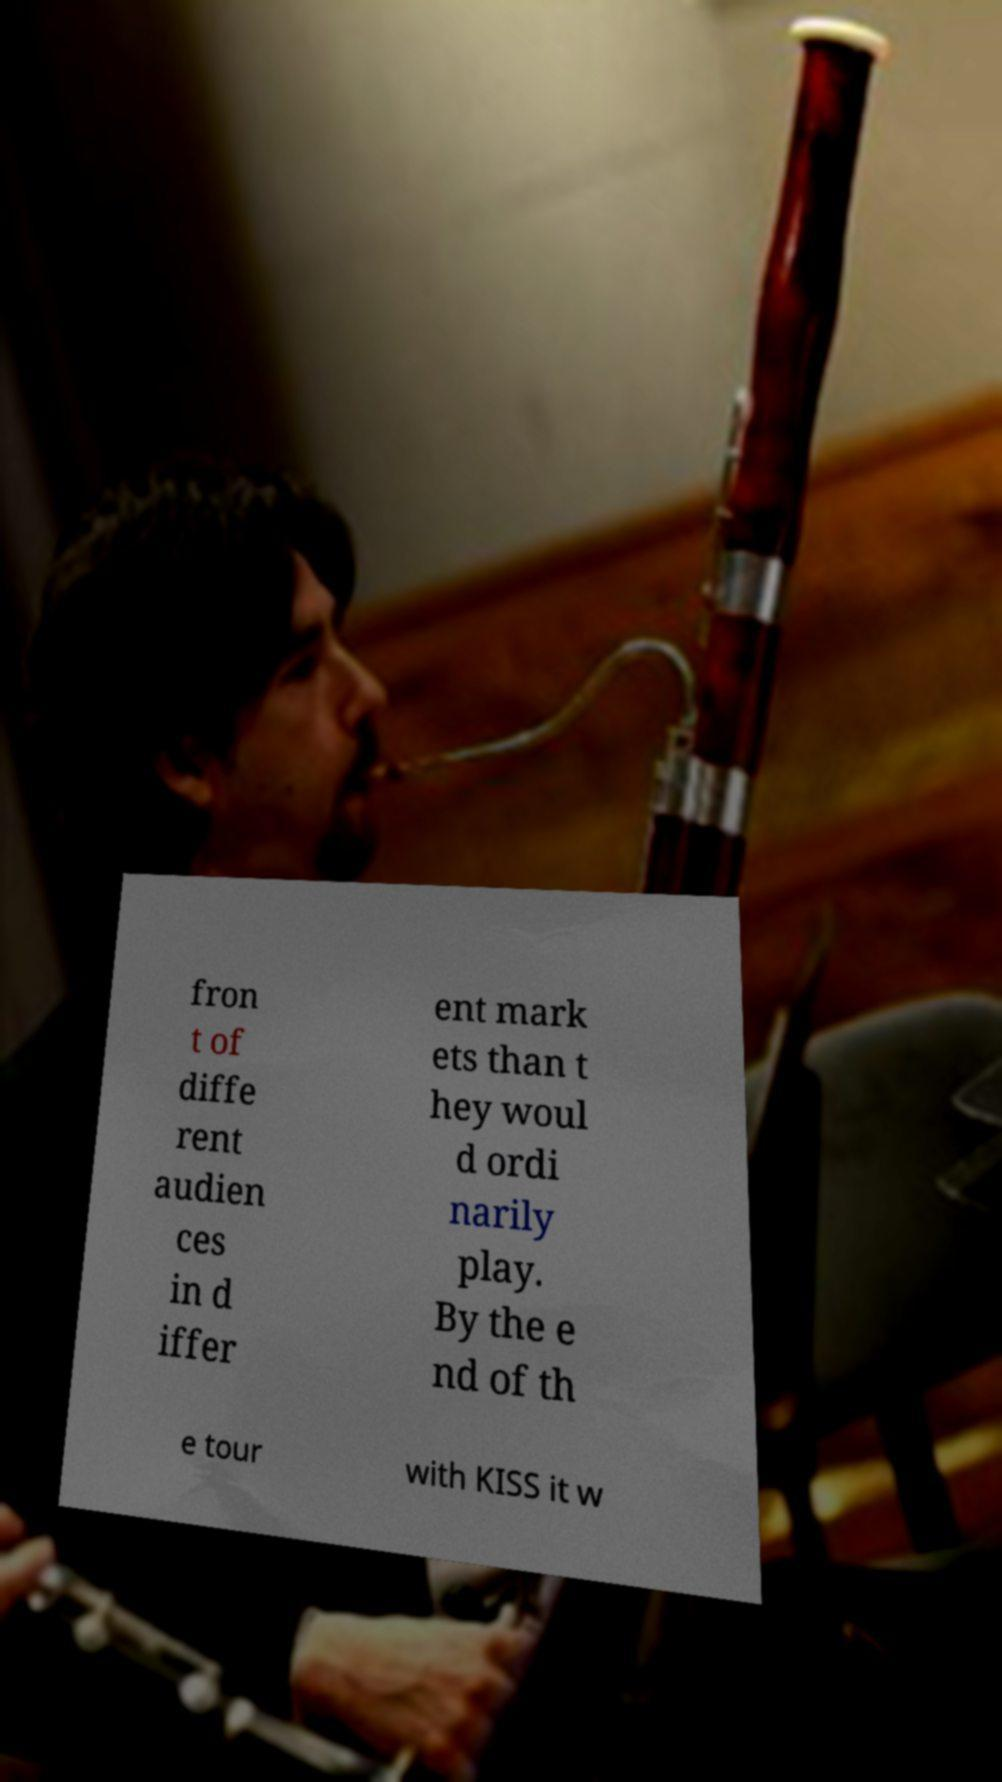For documentation purposes, I need the text within this image transcribed. Could you provide that? fron t of diffe rent audien ces in d iffer ent mark ets than t hey woul d ordi narily play. By the e nd of th e tour with KISS it w 